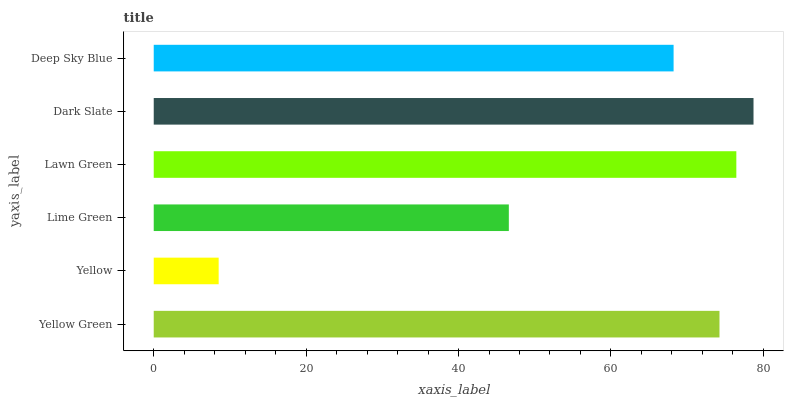Is Yellow the minimum?
Answer yes or no. Yes. Is Dark Slate the maximum?
Answer yes or no. Yes. Is Lime Green the minimum?
Answer yes or no. No. Is Lime Green the maximum?
Answer yes or no. No. Is Lime Green greater than Yellow?
Answer yes or no. Yes. Is Yellow less than Lime Green?
Answer yes or no. Yes. Is Yellow greater than Lime Green?
Answer yes or no. No. Is Lime Green less than Yellow?
Answer yes or no. No. Is Yellow Green the high median?
Answer yes or no. Yes. Is Deep Sky Blue the low median?
Answer yes or no. Yes. Is Lime Green the high median?
Answer yes or no. No. Is Yellow Green the low median?
Answer yes or no. No. 